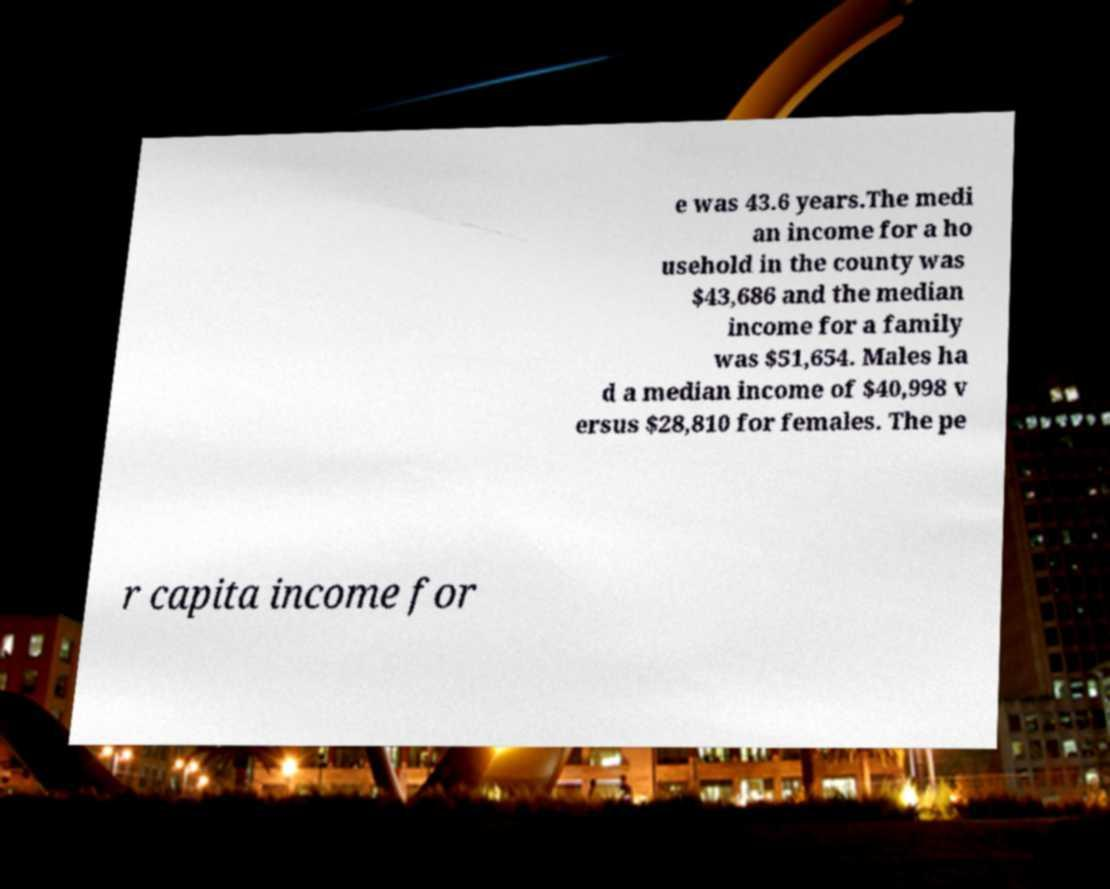What messages or text are displayed in this image? I need them in a readable, typed format. e was 43.6 years.The medi an income for a ho usehold in the county was $43,686 and the median income for a family was $51,654. Males ha d a median income of $40,998 v ersus $28,810 for females. The pe r capita income for 